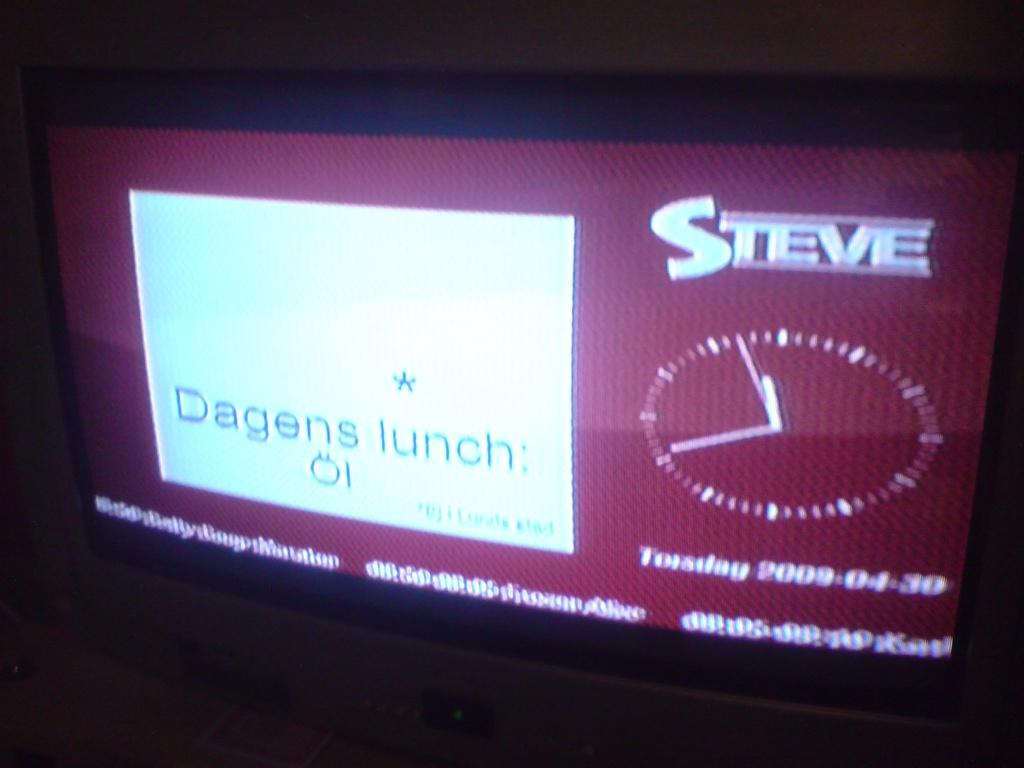<image>
Offer a succinct explanation of the picture presented. A screen that says Dagens lunch  and Steve on it. 